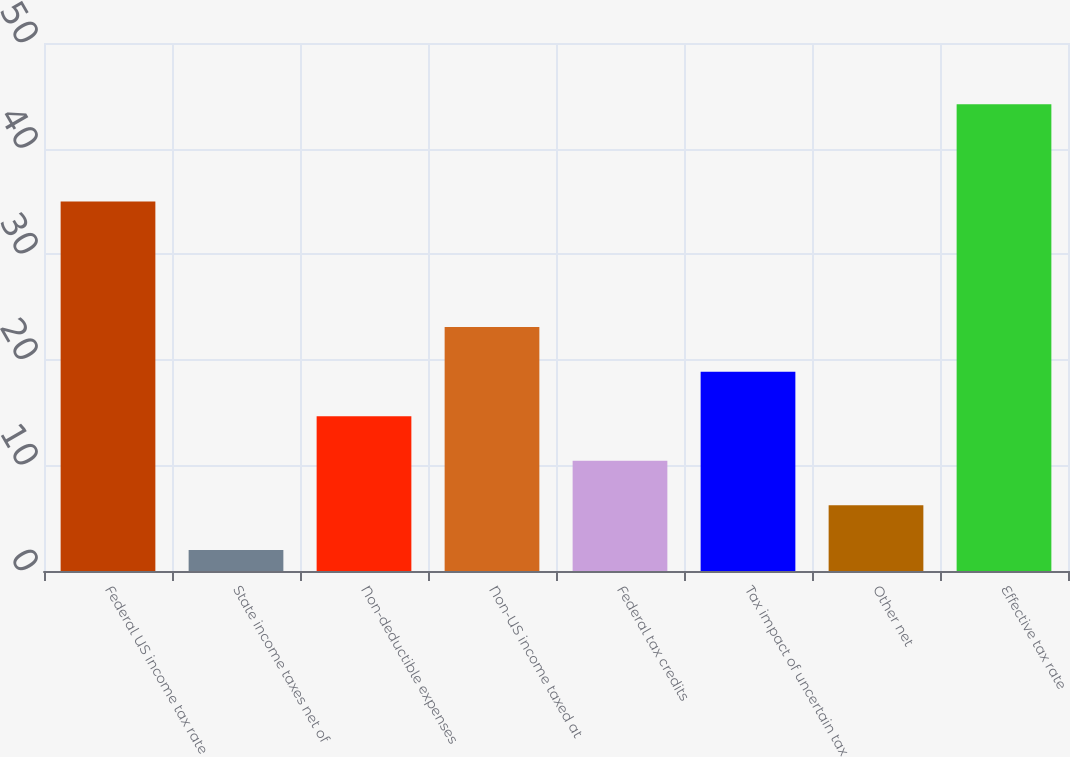<chart> <loc_0><loc_0><loc_500><loc_500><bar_chart><fcel>Federal US income tax rate<fcel>State income taxes net of<fcel>Non-deductible expenses<fcel>Non-US income taxed at<fcel>Federal tax credits<fcel>Tax impact of uncertain tax<fcel>Other net<fcel>Effective tax rate<nl><fcel>35<fcel>2<fcel>14.66<fcel>23.1<fcel>10.44<fcel>18.88<fcel>6.22<fcel>44.2<nl></chart> 